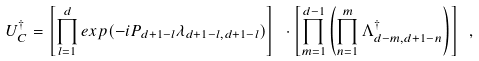Convert formula to latex. <formula><loc_0><loc_0><loc_500><loc_500>U _ { C } ^ { \dagger } = \left [ \prod _ { l = 1 } ^ { d } e x p ( - i P _ { d + 1 - l } \lambda _ { d + 1 - l , d + 1 - l } ) \right ] \ \cdot \left [ \prod _ { m = 1 } ^ { d - 1 } \left ( \prod _ { n = 1 } ^ { m } \Lambda _ { d - m , d + 1 - n } ^ { \dagger } \right ) \right ] \ ,</formula> 